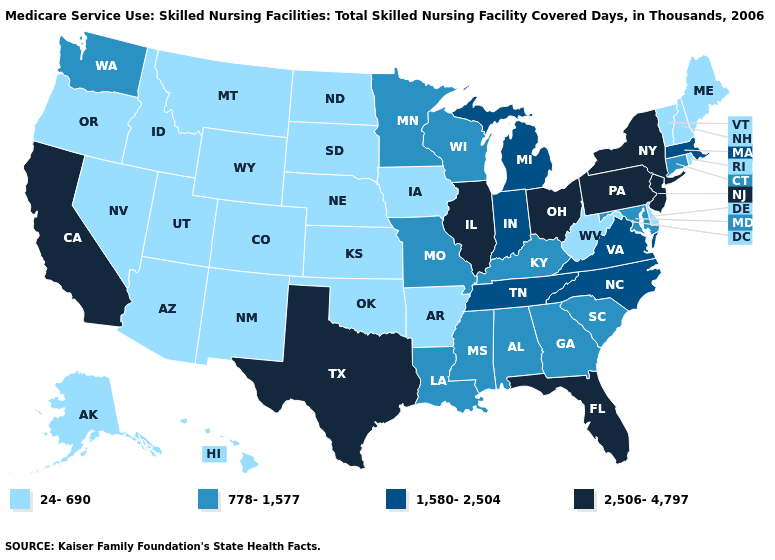What is the lowest value in states that border New Hampshire?
Short answer required. 24-690. Does California have the highest value in the West?
Write a very short answer. Yes. Is the legend a continuous bar?
Quick response, please. No. What is the value of Florida?
Quick response, please. 2,506-4,797. What is the value of Alaska?
Give a very brief answer. 24-690. Does the map have missing data?
Give a very brief answer. No. What is the lowest value in the USA?
Answer briefly. 24-690. What is the lowest value in the South?
Quick response, please. 24-690. Among the states that border Mississippi , which have the highest value?
Short answer required. Tennessee. What is the lowest value in states that border Iowa?
Give a very brief answer. 24-690. What is the value of Arizona?
Write a very short answer. 24-690. How many symbols are there in the legend?
Quick response, please. 4. What is the lowest value in the South?
Be succinct. 24-690. Which states have the lowest value in the USA?
Write a very short answer. Alaska, Arizona, Arkansas, Colorado, Delaware, Hawaii, Idaho, Iowa, Kansas, Maine, Montana, Nebraska, Nevada, New Hampshire, New Mexico, North Dakota, Oklahoma, Oregon, Rhode Island, South Dakota, Utah, Vermont, West Virginia, Wyoming. Which states have the lowest value in the USA?
Keep it brief. Alaska, Arizona, Arkansas, Colorado, Delaware, Hawaii, Idaho, Iowa, Kansas, Maine, Montana, Nebraska, Nevada, New Hampshire, New Mexico, North Dakota, Oklahoma, Oregon, Rhode Island, South Dakota, Utah, Vermont, West Virginia, Wyoming. 